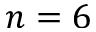Convert formula to latex. <formula><loc_0><loc_0><loc_500><loc_500>n = 6</formula> 